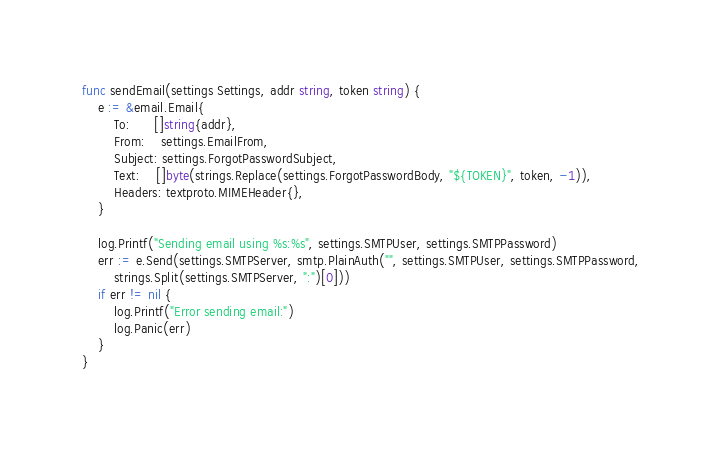<code> <loc_0><loc_0><loc_500><loc_500><_Go_>
func sendEmail(settings Settings, addr string, token string) {
	e := &email.Email{
		To:      []string{addr},
		From:    settings.EmailFrom,
		Subject: settings.ForgotPasswordSubject,
		Text:    []byte(strings.Replace(settings.ForgotPasswordBody, "${TOKEN}", token, -1)),
		Headers: textproto.MIMEHeader{},
	}

	log.Printf("Sending email using %s:%s", settings.SMTPUser, settings.SMTPPassword)
	err := e.Send(settings.SMTPServer, smtp.PlainAuth("", settings.SMTPUser, settings.SMTPPassword,
		strings.Split(settings.SMTPServer, ":")[0]))
	if err != nil {
		log.Printf("Error sending email:")
		log.Panic(err)
	}
}
</code> 